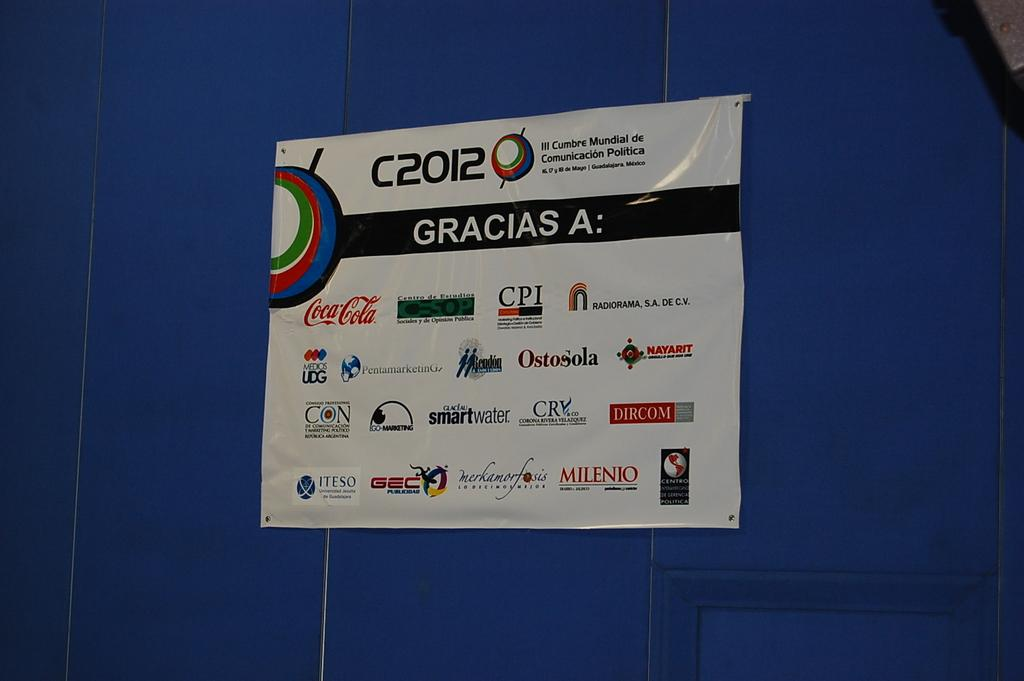<image>
Relay a brief, clear account of the picture shown. A poster with several logos on it hangs on a wall. 